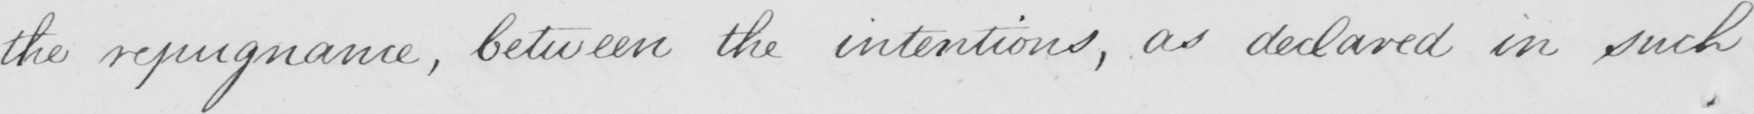What does this handwritten line say? the repugnance , between the intentions , as declared in such 